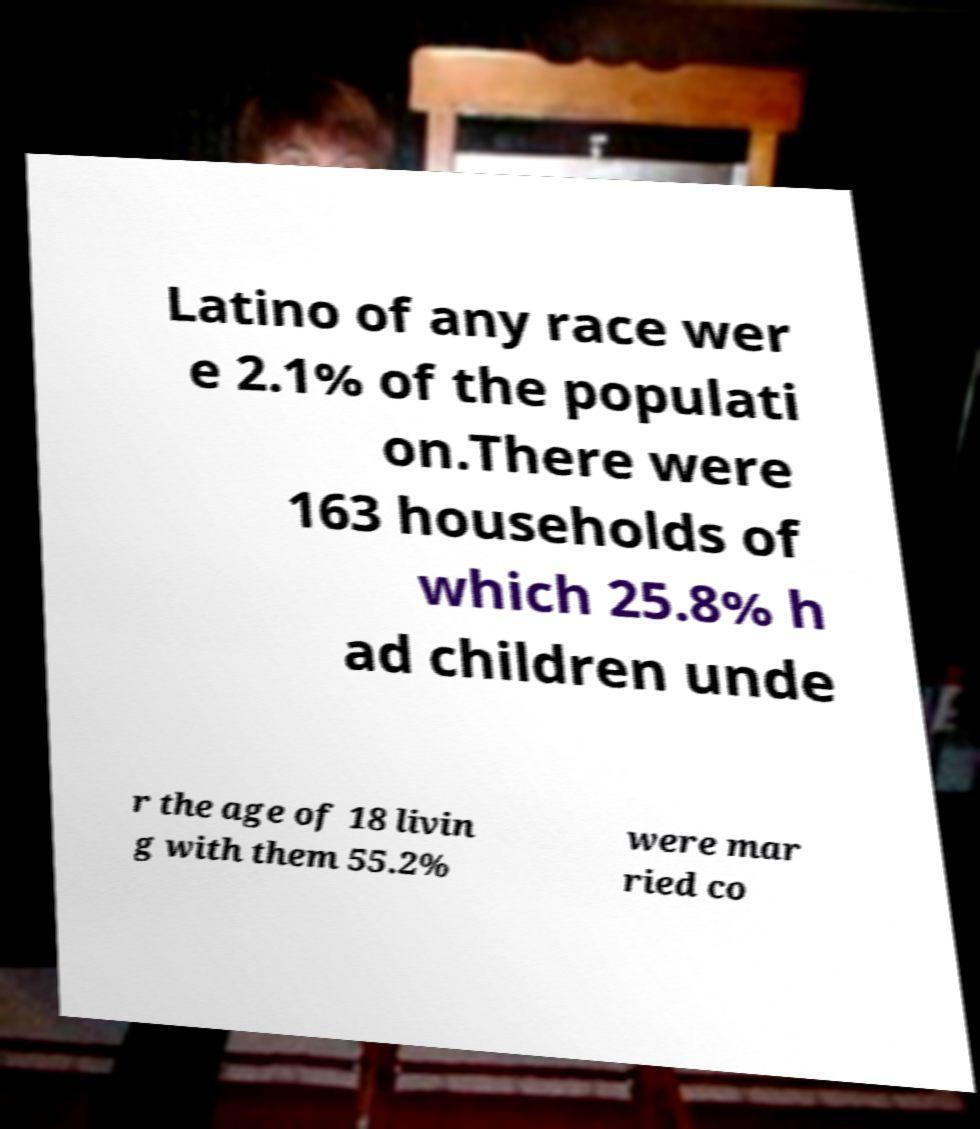Please identify and transcribe the text found in this image. Latino of any race wer e 2.1% of the populati on.There were 163 households of which 25.8% h ad children unde r the age of 18 livin g with them 55.2% were mar ried co 